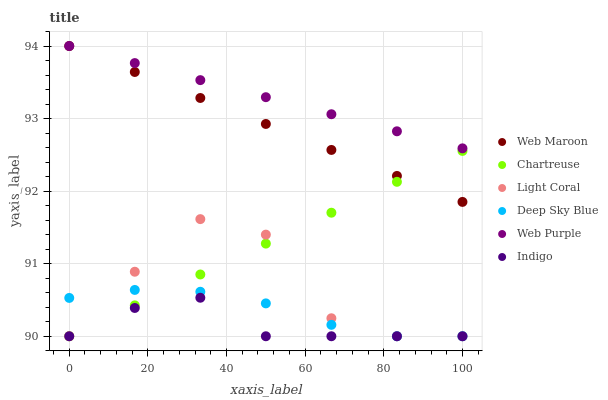Does Indigo have the minimum area under the curve?
Answer yes or no. Yes. Does Web Purple have the maximum area under the curve?
Answer yes or no. Yes. Does Web Maroon have the minimum area under the curve?
Answer yes or no. No. Does Web Maroon have the maximum area under the curve?
Answer yes or no. No. Is Web Maroon the smoothest?
Answer yes or no. Yes. Is Light Coral the roughest?
Answer yes or no. Yes. Is Web Purple the smoothest?
Answer yes or no. No. Is Web Purple the roughest?
Answer yes or no. No. Does Indigo have the lowest value?
Answer yes or no. Yes. Does Web Maroon have the lowest value?
Answer yes or no. No. Does Web Purple have the highest value?
Answer yes or no. Yes. Does Light Coral have the highest value?
Answer yes or no. No. Is Chartreuse less than Web Purple?
Answer yes or no. Yes. Is Web Purple greater than Light Coral?
Answer yes or no. Yes. Does Indigo intersect Chartreuse?
Answer yes or no. Yes. Is Indigo less than Chartreuse?
Answer yes or no. No. Is Indigo greater than Chartreuse?
Answer yes or no. No. Does Chartreuse intersect Web Purple?
Answer yes or no. No. 